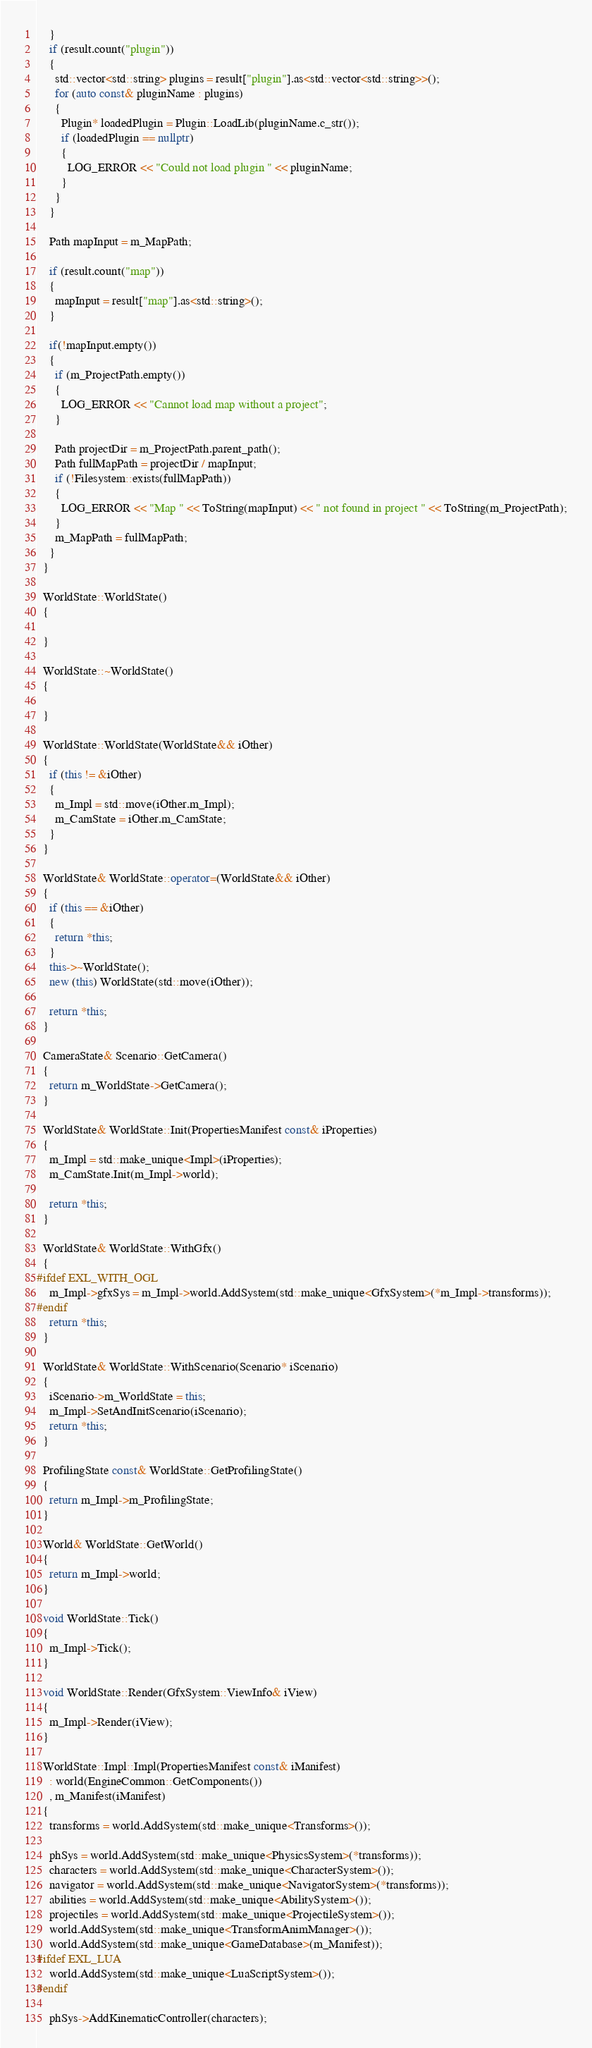<code> <loc_0><loc_0><loc_500><loc_500><_C++_>    }
    if (result.count("plugin"))
    {
      std::vector<std::string> plugins = result["plugin"].as<std::vector<std::string>>();
      for (auto const& pluginName : plugins)
      {
        Plugin* loadedPlugin = Plugin::LoadLib(pluginName.c_str());
        if (loadedPlugin == nullptr)
        {
          LOG_ERROR << "Could not load plugin " << pluginName;
        }
      }
    }
    
    Path mapInput = m_MapPath;

    if (result.count("map"))
    {
      mapInput = result["map"].as<std::string>();
    }

    if(!mapInput.empty())
    {
      if (m_ProjectPath.empty())
      {
        LOG_ERROR << "Cannot load map without a project";
      }

      Path projectDir = m_ProjectPath.parent_path();
      Path fullMapPath = projectDir / mapInput;
      if (!Filesystem::exists(fullMapPath))
      {
        LOG_ERROR << "Map " << ToString(mapInput) << " not found in project " << ToString(m_ProjectPath);
      }
      m_MapPath = fullMapPath;
    }
  }

  WorldState::WorldState()
  {

  }

  WorldState::~WorldState()
  {

  }

  WorldState::WorldState(WorldState&& iOther)
  {
    if (this != &iOther)
    {
      m_Impl = std::move(iOther.m_Impl);
      m_CamState = iOther.m_CamState;
    }
  }

  WorldState& WorldState::operator=(WorldState&& iOther)
  {
    if (this == &iOther)
    {
      return *this;
    }
    this->~WorldState();
    new (this) WorldState(std::move(iOther));

    return *this;
  }

  CameraState& Scenario::GetCamera()
  {
    return m_WorldState->GetCamera();
  }

  WorldState& WorldState::Init(PropertiesManifest const& iProperties)
  {
    m_Impl = std::make_unique<Impl>(iProperties);
    m_CamState.Init(m_Impl->world);

    return *this;
  }

  WorldState& WorldState::WithGfx()
  {
#ifdef EXL_WITH_OGL
    m_Impl->gfxSys = m_Impl->world.AddSystem(std::make_unique<GfxSystem>(*m_Impl->transforms));
#endif
    return *this;
  }

  WorldState& WorldState::WithScenario(Scenario* iScenario)
  {
    iScenario->m_WorldState = this;
    m_Impl->SetAndInitScenario(iScenario);
    return *this;
  }

  ProfilingState const& WorldState::GetProfilingState()
  {
    return m_Impl->m_ProfilingState;
  }

  World& WorldState::GetWorld()
  {
    return m_Impl->world;
  }

  void WorldState::Tick()
  {
    m_Impl->Tick();
  }

  void WorldState::Render(GfxSystem::ViewInfo& iView)
  {
    m_Impl->Render(iView);
  }

  WorldState::Impl::Impl(PropertiesManifest const& iManifest)
    : world(EngineCommon::GetComponents())
    , m_Manifest(iManifest)
  {
    transforms = world.AddSystem(std::make_unique<Transforms>());

    phSys = world.AddSystem(std::make_unique<PhysicsSystem>(*transforms));
    characters = world.AddSystem(std::make_unique<CharacterSystem>());
    navigator = world.AddSystem(std::make_unique<NavigatorSystem>(*transforms));
    abilities = world.AddSystem(std::make_unique<AbilitySystem>());
    projectiles = world.AddSystem(std::make_unique<ProjectileSystem>());
    world.AddSystem(std::make_unique<TransformAnimManager>());
    world.AddSystem(std::make_unique<GameDatabase>(m_Manifest));
#ifdef EXL_LUA
    world.AddSystem(std::make_unique<LuaScriptSystem>());
#endif

    phSys->AddKinematicController(characters);</code> 